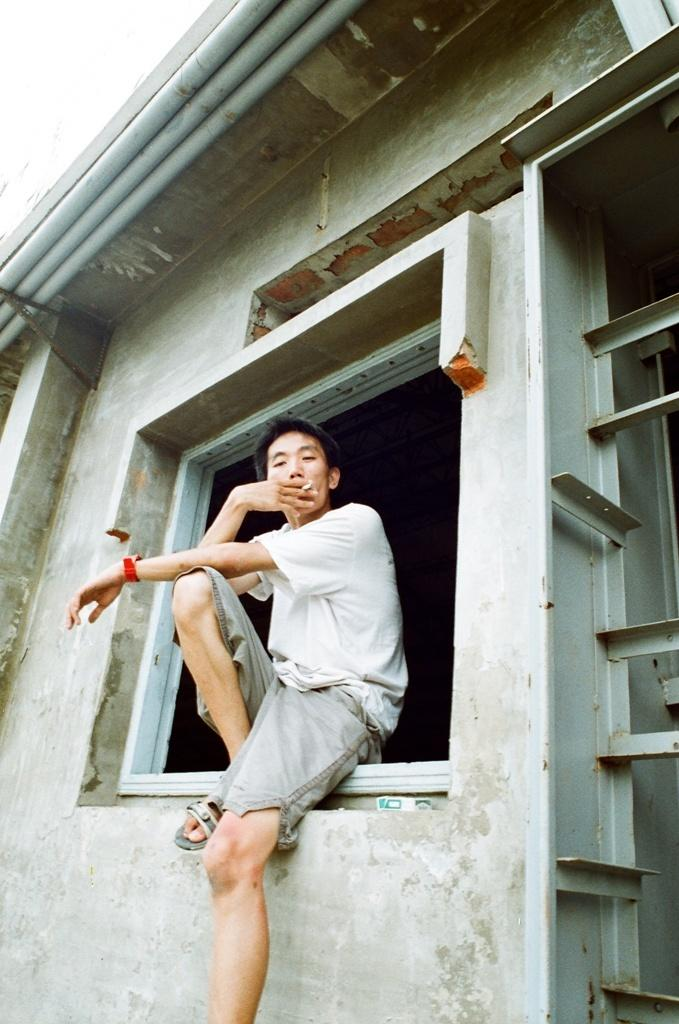Who or what is present in the image? There is a person in the image. What is the person wearing? The person is wearing clothes. What is the person doing in the image? The person is sitting on a window. What can be seen in the top left of the image? There are pipes in the top left of the image. What type of wheel can be seen in the image? There is no wheel present in the image. Is the person's uncle also in the image? The provided facts do not mention the presence of an uncle, so it cannot be determined from the image. 